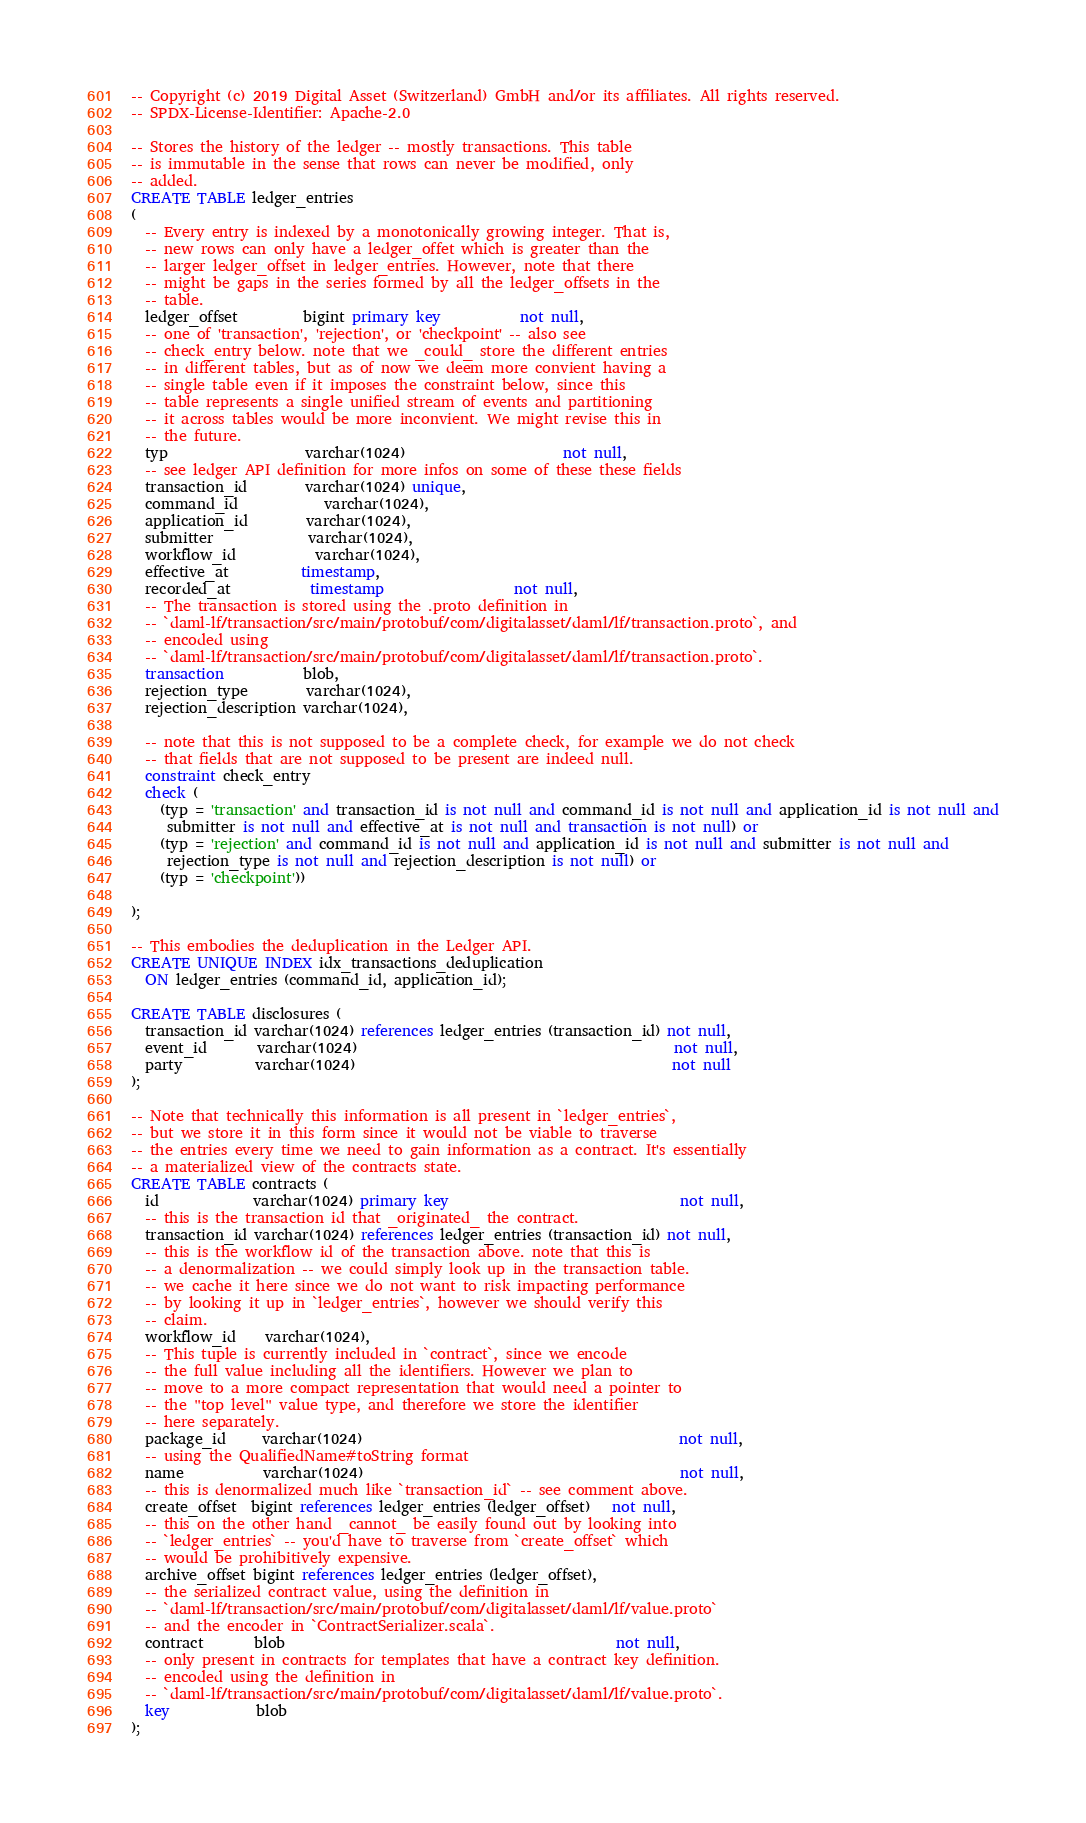Convert code to text. <code><loc_0><loc_0><loc_500><loc_500><_SQL_>-- Copyright (c) 2019 Digital Asset (Switzerland) GmbH and/or its affiliates. All rights reserved.
-- SPDX-License-Identifier: Apache-2.0

-- Stores the history of the ledger -- mostly transactions. This table
-- is immutable in the sense that rows can never be modified, only
-- added.
CREATE TABLE ledger_entries
(
  -- Every entry is indexed by a monotonically growing integer. That is,
  -- new rows can only have a ledger_offet which is greater than the
  -- larger ledger_offset in ledger_entries. However, note that there
  -- might be gaps in the series formed by all the ledger_offsets in the
  -- table.
  ledger_offset         bigint primary key           not null,
  -- one of 'transaction', 'rejection', or 'checkpoint' -- also see
  -- check_entry below. note that we _could_ store the different entries
  -- in different tables, but as of now we deem more convient having a
  -- single table even if it imposes the constraint below, since this
  -- table represents a single unified stream of events and partitioning
  -- it across tables would be more inconvient. We might revise this in
  -- the future.
  typ                   varchar(1024)                      not null,
  -- see ledger API definition for more infos on some of these these fields
  transaction_id        varchar(1024) unique,
  command_id            varchar(1024),
  application_id        varchar(1024),
  submitter             varchar(1024),
  workflow_id           varchar(1024),
  effective_at          timestamp,
  recorded_at           timestamp                  not null,
  -- The transaction is stored using the .proto definition in
  -- `daml-lf/transaction/src/main/protobuf/com/digitalasset/daml/lf/transaction.proto`, and
  -- encoded using
  -- `daml-lf/transaction/src/main/protobuf/com/digitalasset/daml/lf/transaction.proto`.
  transaction           blob,
  rejection_type        varchar(1024),
  rejection_description varchar(1024),

  -- note that this is not supposed to be a complete check, for example we do not check
  -- that fields that are not supposed to be present are indeed null.
  constraint check_entry
  check (
    (typ = 'transaction' and transaction_id is not null and command_id is not null and application_id is not null and
     submitter is not null and effective_at is not null and transaction is not null) or
    (typ = 'rejection' and command_id is not null and application_id is not null and submitter is not null and
     rejection_type is not null and rejection_description is not null) or
    (typ = 'checkpoint'))

);

-- This embodies the deduplication in the Ledger API.
CREATE UNIQUE INDEX idx_transactions_deduplication
  ON ledger_entries (command_id, application_id);

CREATE TABLE disclosures (
  transaction_id varchar(1024) references ledger_entries (transaction_id) not null,
  event_id       varchar(1024)                                            not null,
  party          varchar(1024)                                            not null
);

-- Note that technically this information is all present in `ledger_entries`,
-- but we store it in this form since it would not be viable to traverse
-- the entries every time we need to gain information as a contract. It's essentially
-- a materialized view of the contracts state.
CREATE TABLE contracts (
  id             varchar(1024) primary key                                not null,
  -- this is the transaction id that _originated_ the contract.
  transaction_id varchar(1024) references ledger_entries (transaction_id) not null,
  -- this is the workflow id of the transaction above. note that this is
  -- a denormalization -- we could simply look up in the transaction table.
  -- we cache it here since we do not want to risk impacting performance
  -- by looking it up in `ledger_entries`, however we should verify this
  -- claim.
  workflow_id    varchar(1024),
  -- This tuple is currently included in `contract`, since we encode
  -- the full value including all the identifiers. However we plan to
  -- move to a more compact representation that would need a pointer to
  -- the "top level" value type, and therefore we store the identifier
  -- here separately.
  package_id     varchar(1024)                                            not null,
  -- using the QualifiedName#toString format
  name           varchar(1024)                                            not null,
  -- this is denormalized much like `transaction_id` -- see comment above.
  create_offset  bigint references ledger_entries (ledger_offset)   not null,
  -- this on the other hand _cannot_ be easily found out by looking into
  -- `ledger_entries` -- you'd have to traverse from `create_offset` which
  -- would be prohibitively expensive.
  archive_offset bigint references ledger_entries (ledger_offset),
  -- the serialized contract value, using the definition in
  -- `daml-lf/transaction/src/main/protobuf/com/digitalasset/daml/lf/value.proto`
  -- and the encoder in `ContractSerializer.scala`.
  contract       blob                                              not null,
  -- only present in contracts for templates that have a contract key definition.
  -- encoded using the definition in
  -- `daml-lf/transaction/src/main/protobuf/com/digitalasset/daml/lf/value.proto`.
  key            blob
);
</code> 